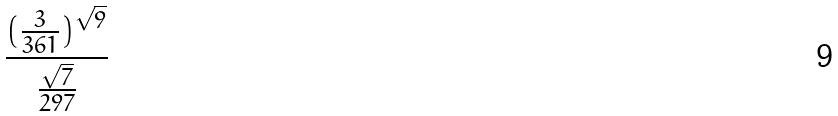Convert formula to latex. <formula><loc_0><loc_0><loc_500><loc_500>\frac { ( \frac { 3 } { 3 6 1 } ) ^ { \sqrt { 9 } } } { \frac { \sqrt { 7 } } { 2 9 7 } }</formula> 